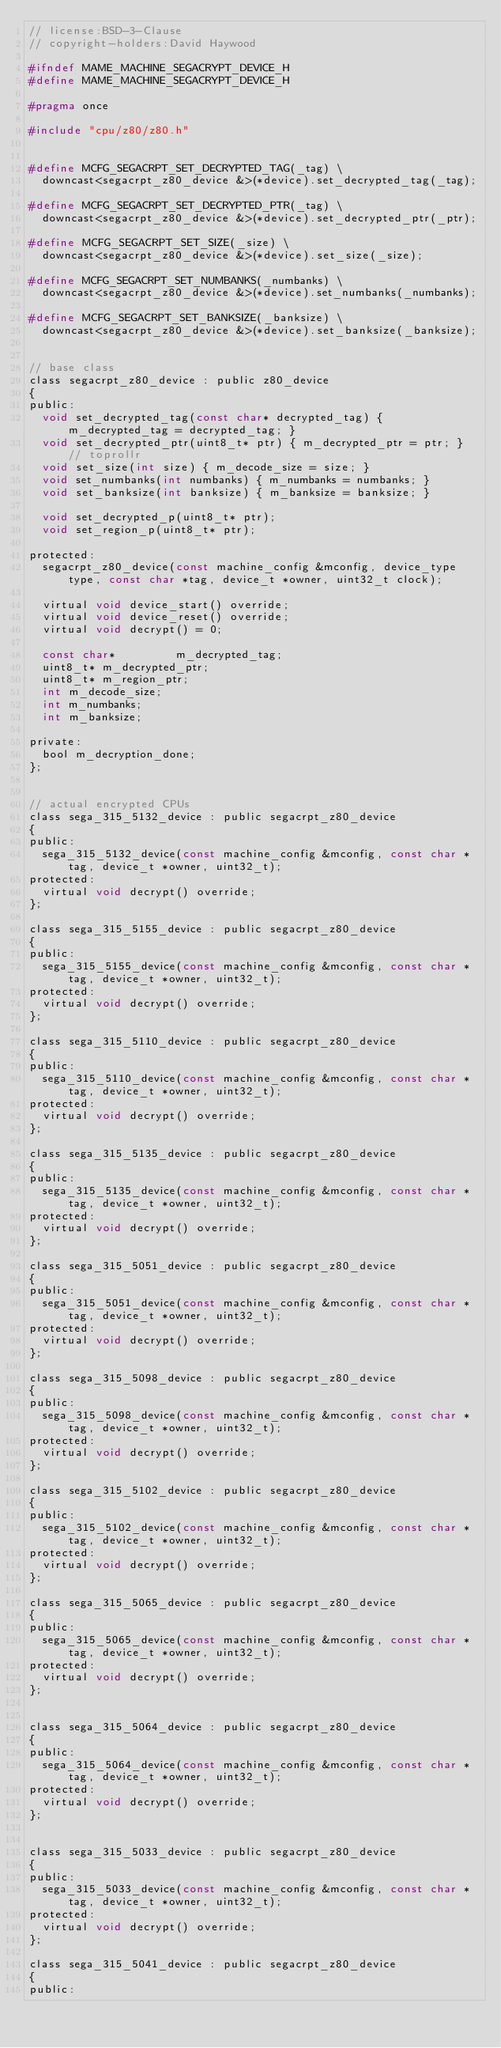<code> <loc_0><loc_0><loc_500><loc_500><_C_>// license:BSD-3-Clause
// copyright-holders:David Haywood

#ifndef MAME_MACHINE_SEGACRYPT_DEVICE_H
#define MAME_MACHINE_SEGACRYPT_DEVICE_H

#pragma once

#include "cpu/z80/z80.h"


#define MCFG_SEGACRPT_SET_DECRYPTED_TAG(_tag) \
	downcast<segacrpt_z80_device &>(*device).set_decrypted_tag(_tag);

#define MCFG_SEGACRPT_SET_DECRYPTED_PTR(_tag) \
	downcast<segacrpt_z80_device &>(*device).set_decrypted_ptr(_ptr);

#define MCFG_SEGACRPT_SET_SIZE(_size) \
	downcast<segacrpt_z80_device &>(*device).set_size(_size);

#define MCFG_SEGACRPT_SET_NUMBANKS(_numbanks) \
	downcast<segacrpt_z80_device &>(*device).set_numbanks(_numbanks);

#define MCFG_SEGACRPT_SET_BANKSIZE(_banksize) \
	downcast<segacrpt_z80_device &>(*device).set_banksize(_banksize);


// base class
class segacrpt_z80_device : public z80_device
{
public:
	void set_decrypted_tag(const char* decrypted_tag) { m_decrypted_tag = decrypted_tag; }
	void set_decrypted_ptr(uint8_t* ptr) { m_decrypted_ptr = ptr; } // toprollr
	void set_size(int size) { m_decode_size = size; }
	void set_numbanks(int numbanks) { m_numbanks = numbanks; }
	void set_banksize(int banksize) { m_banksize = banksize; }

	void set_decrypted_p(uint8_t* ptr);
	void set_region_p(uint8_t* ptr);

protected:
	segacrpt_z80_device(const machine_config &mconfig, device_type type, const char *tag, device_t *owner, uint32_t clock);

	virtual void device_start() override;
	virtual void device_reset() override;
	virtual void decrypt() = 0;

	const char*         m_decrypted_tag;
	uint8_t* m_decrypted_ptr;
	uint8_t* m_region_ptr;
	int m_decode_size;
	int m_numbanks;
	int m_banksize;

private:
	bool m_decryption_done;
};


// actual encrypted CPUs
class sega_315_5132_device : public segacrpt_z80_device
{
public:
	sega_315_5132_device(const machine_config &mconfig, const char *tag, device_t *owner, uint32_t);
protected:
	virtual void decrypt() override;
};

class sega_315_5155_device : public segacrpt_z80_device
{
public:
	sega_315_5155_device(const machine_config &mconfig, const char *tag, device_t *owner, uint32_t);
protected:
	virtual void decrypt() override;
};

class sega_315_5110_device : public segacrpt_z80_device
{
public:
	sega_315_5110_device(const machine_config &mconfig, const char *tag, device_t *owner, uint32_t);
protected:
	virtual void decrypt() override;
};

class sega_315_5135_device : public segacrpt_z80_device
{
public:
	sega_315_5135_device(const machine_config &mconfig, const char *tag, device_t *owner, uint32_t);
protected:
	virtual void decrypt() override;
};

class sega_315_5051_device : public segacrpt_z80_device
{
public:
	sega_315_5051_device(const machine_config &mconfig, const char *tag, device_t *owner, uint32_t);
protected:
	virtual void decrypt() override;
};

class sega_315_5098_device : public segacrpt_z80_device
{
public:
	sega_315_5098_device(const machine_config &mconfig, const char *tag, device_t *owner, uint32_t);
protected:
	virtual void decrypt() override;
};

class sega_315_5102_device : public segacrpt_z80_device
{
public:
	sega_315_5102_device(const machine_config &mconfig, const char *tag, device_t *owner, uint32_t);
protected:
	virtual void decrypt() override;
};

class sega_315_5065_device : public segacrpt_z80_device
{
public:
	sega_315_5065_device(const machine_config &mconfig, const char *tag, device_t *owner, uint32_t);
protected:
	virtual void decrypt() override;
};


class sega_315_5064_device : public segacrpt_z80_device
{
public:
	sega_315_5064_device(const machine_config &mconfig, const char *tag, device_t *owner, uint32_t);
protected:
	virtual void decrypt() override;
};


class sega_315_5033_device : public segacrpt_z80_device
{
public:
	sega_315_5033_device(const machine_config &mconfig, const char *tag, device_t *owner, uint32_t);
protected:
	virtual void decrypt() override;
};

class sega_315_5041_device : public segacrpt_z80_device
{
public:</code> 